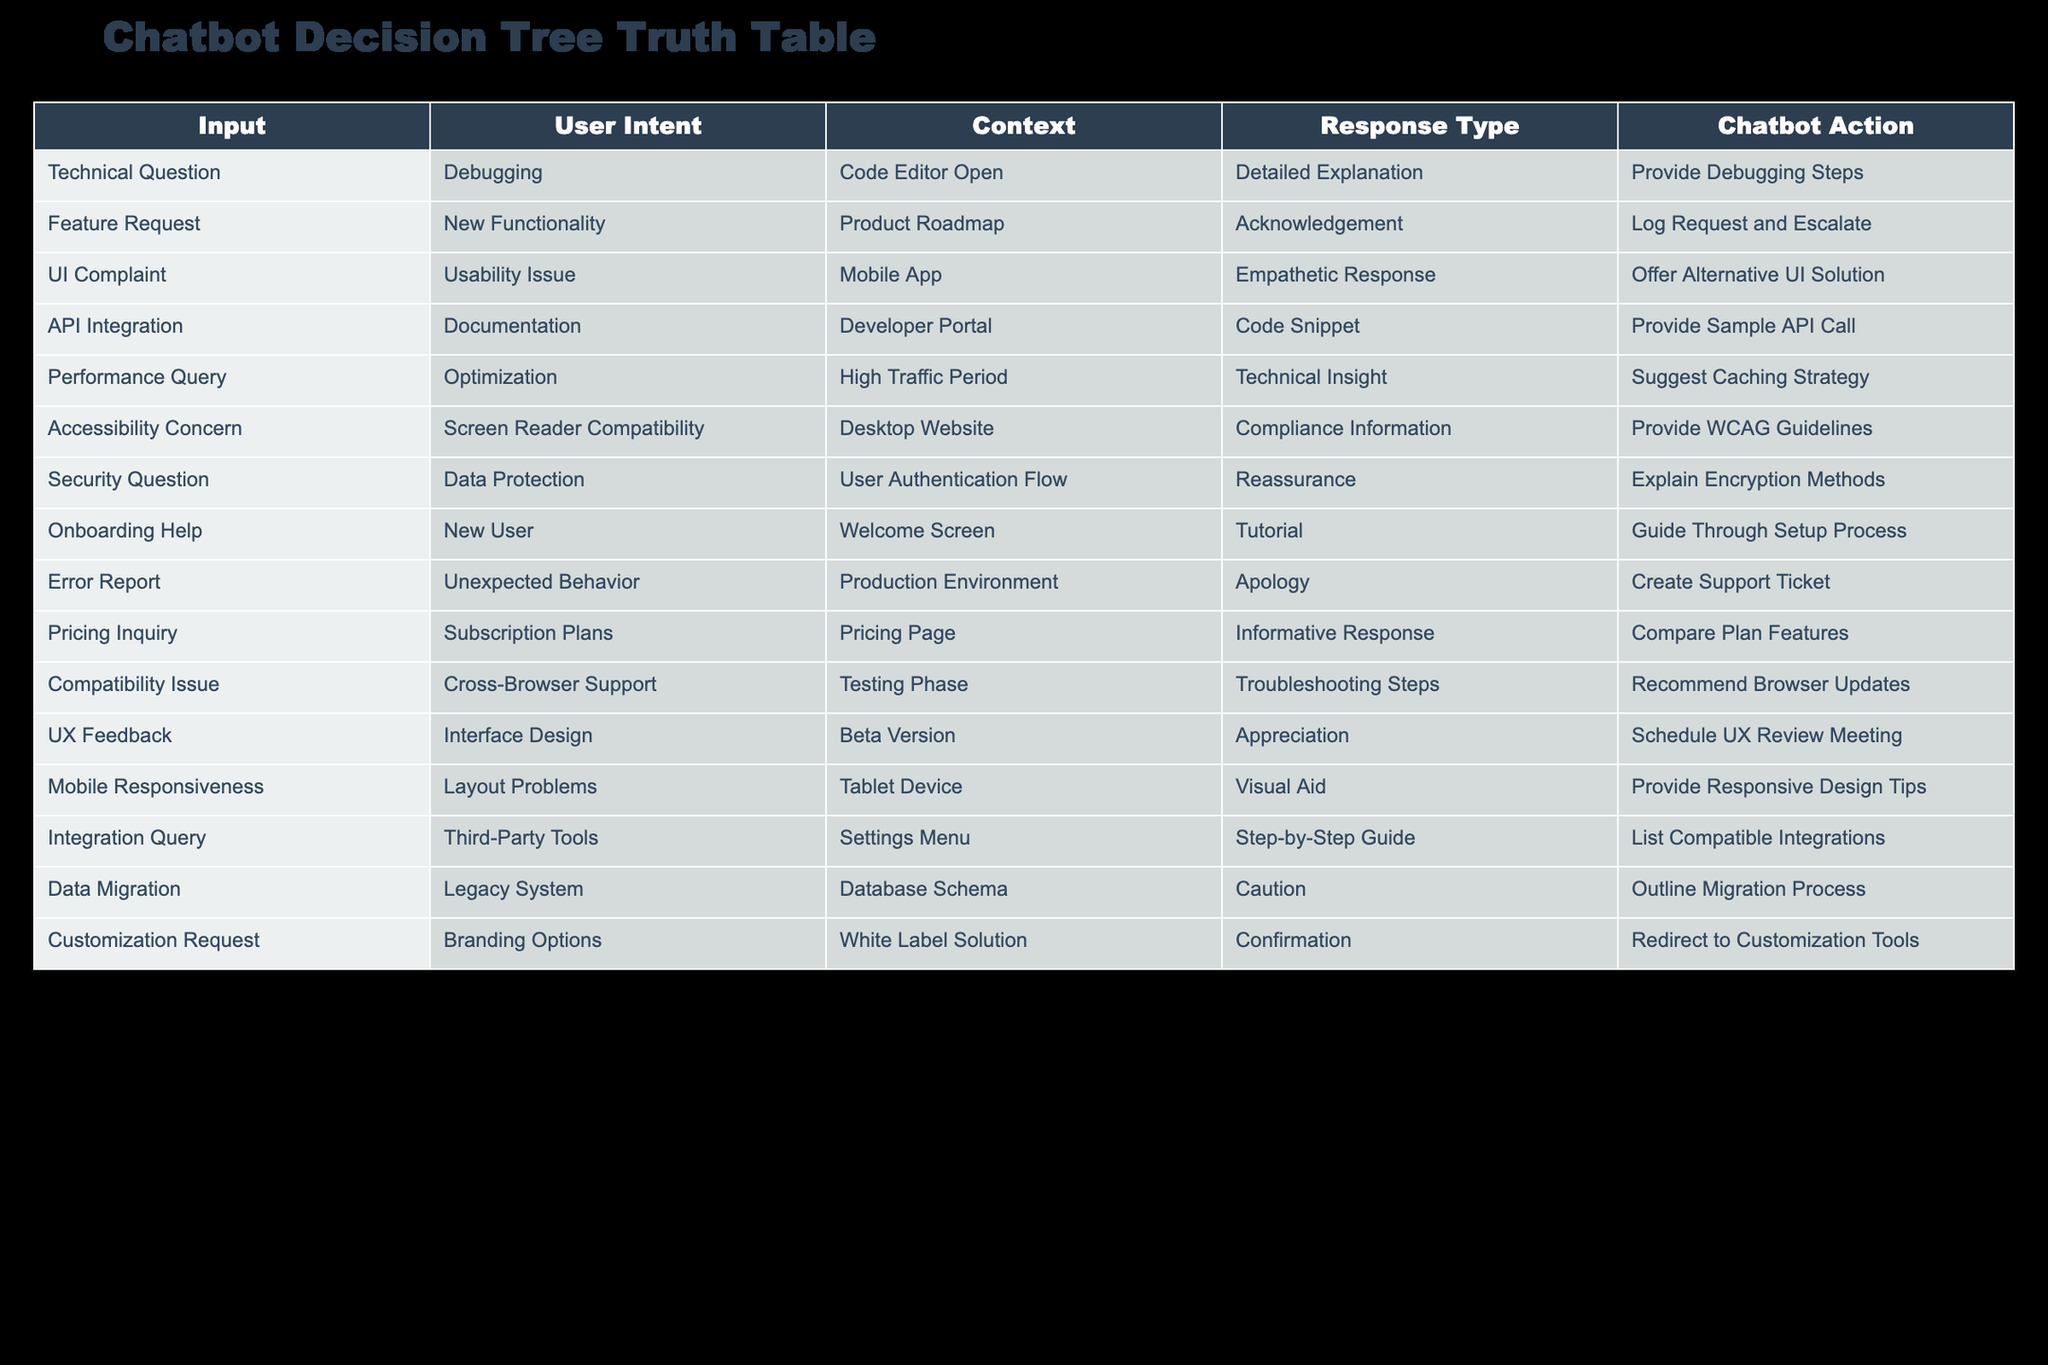What user intent is associated with providing a code snippet? By looking at the table, I can see that the user intent "API Integration" is listed under the "User Intent" column, which corresponds to the response type "Code Snippet."
Answer: API Integration What response type is used when a user reports an error? The table indicates that the response type for the user intent "Error Report" is "Apology," which can be directly read from the cells under the relevant columns.
Answer: Apology How many different response types are associated with "Technical Question"? One looks at the table and sees that the user intent "Technical Question" corresponds to the response type "Detailed Explanation." Thus, there is one response type associated with it.
Answer: 1 Is there a response type that involves offering alternative solutions? By inspecting the table, I find that "UI Complaint" uses an "Empathetic Response," which aims to provide an alternative solution. This confirms that yes, there is a response type that involves offering alternatives.
Answer: Yes What is the technical insight provided when users face a performance query? From the table, I observe that under the user intent "Performance Query," the response type is "Technical Insight," which relates to a caching strategy suggestion.
Answer: Suggest Caching Strategy How many user intents require empathetic responses? By scanning the table, I see that "UI Complaint" is the only user intent that requires an empathetic response. This tallies it to one.
Answer: 1 What is the response to a feature request? Referring to the data, the user intent "Feature Request" returns an "Acknowledgement" in the response type. Therefore, the response to a feature request is an acknowledgment.
Answer: Acknowledgement Which user intent is associated with a cautious response type? The "Data Migration" user intent is associated with the response type "Caution," as indicated in the table. This confirms that "Data Migration" is the user intent linked with a cautious response.
Answer: Data Migration What is the difference between the response types for debugging and API integration? The response type for "Technical Question" related to debugging is "Detailed Explanation," while for "API Integration," it is "Code Snippet." Thus, the difference is that one focuses on explanation while the other provides a code snippet.
Answer: Detailed Explanation vs Code Snippet 